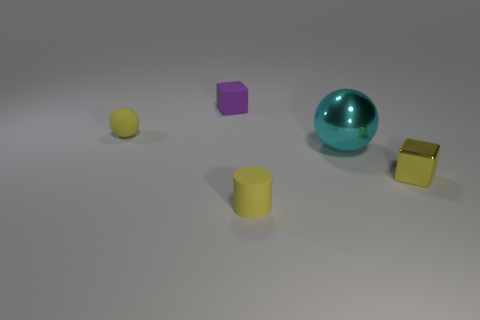Is there any other thing that has the same material as the big cyan ball?
Offer a terse response. Yes. Are there any other things that are the same size as the metallic sphere?
Offer a very short reply. No. There is a small cylinder that is the same color as the matte sphere; what is it made of?
Ensure brevity in your answer.  Rubber. What material is the large thing?
Keep it short and to the point. Metal. There is a small shiny thing; does it have the same color as the tiny cube left of the tiny rubber cylinder?
Your answer should be compact. No. What number of tiny yellow cylinders are in front of the cyan thing?
Offer a very short reply. 1. Are there fewer shiny objects that are behind the purple object than large cyan metallic spheres?
Keep it short and to the point. Yes. What color is the cylinder?
Offer a very short reply. Yellow. There is a small thing that is right of the large metallic sphere; is it the same color as the small cylinder?
Make the answer very short. Yes. There is another thing that is the same shape as the yellow metal thing; what color is it?
Provide a short and direct response. Purple. 